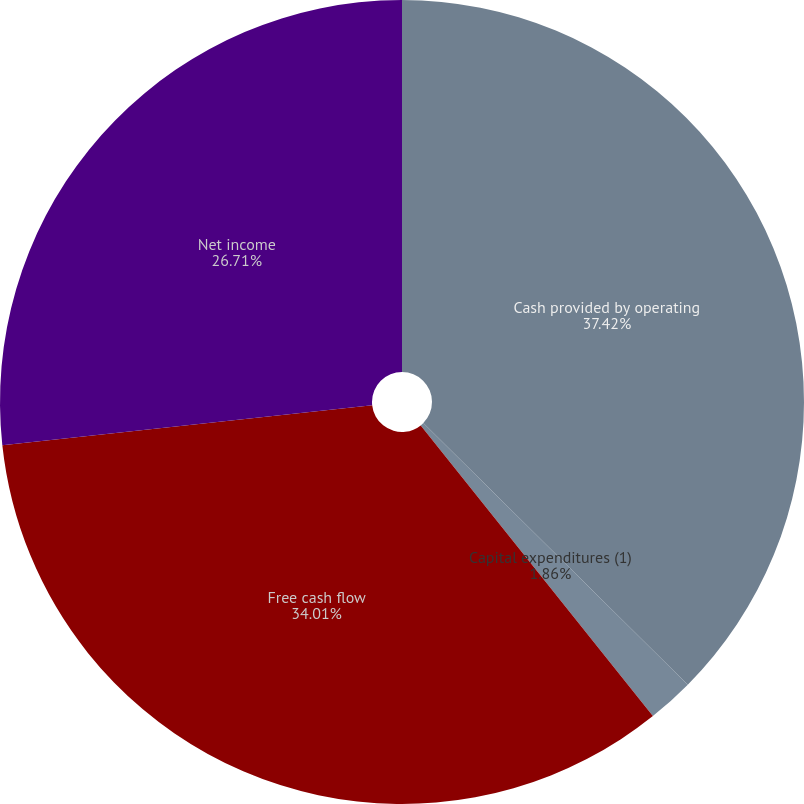<chart> <loc_0><loc_0><loc_500><loc_500><pie_chart><fcel>Cash provided by operating<fcel>Capital expenditures (1)<fcel>Free cash flow<fcel>Net income<nl><fcel>37.41%<fcel>1.86%<fcel>34.01%<fcel>26.71%<nl></chart> 